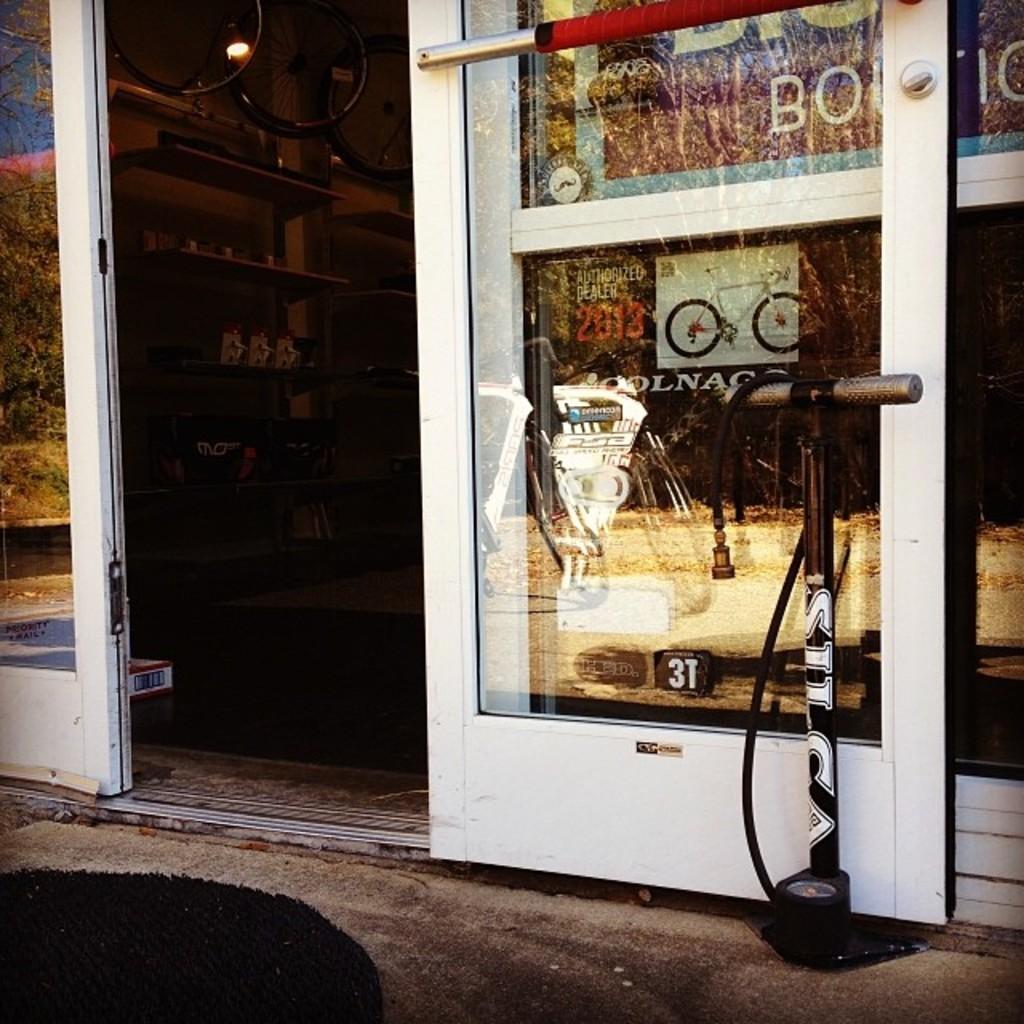Can you describe this image briefly? It is a picture of a store. In this picture I can see door, racks, wheels, light and objects. 